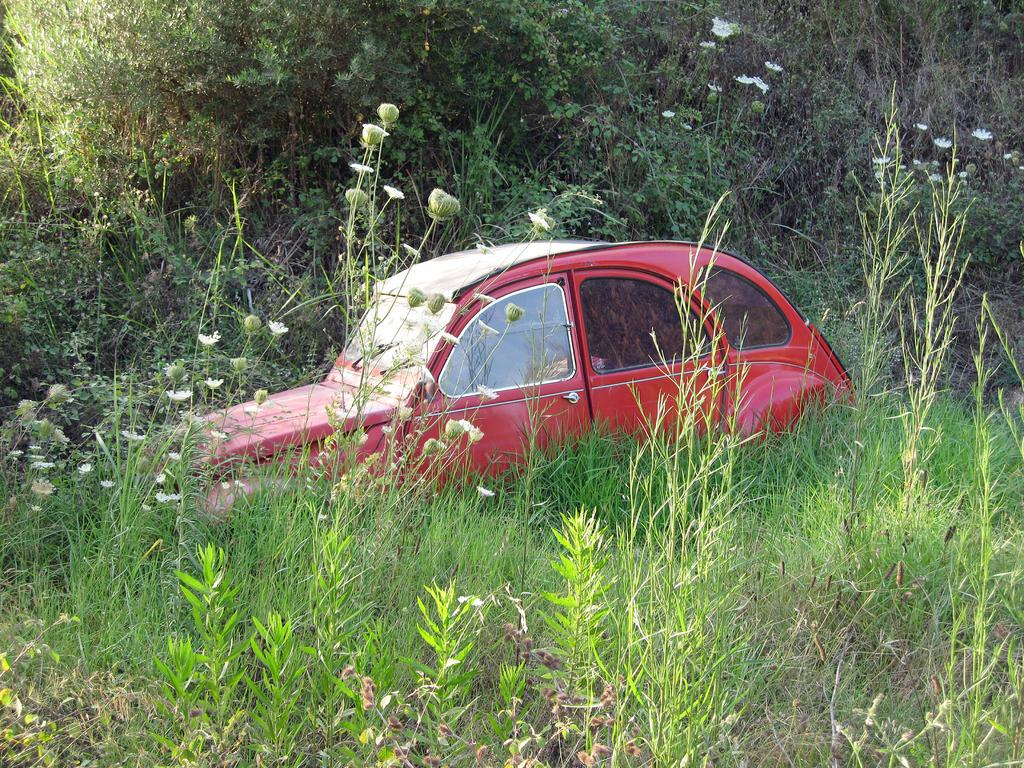What color is the car in the image? The car in the image is red. What can be seen around the car? Plants and grass are visible around the car. Are there any other natural elements in the image? Yes, trees are present in the image. What type of soup is being served in the image? There is no soup present in the image; it features a red car surrounded by plants, grass, and trees. Is there a book visible in the image? There is no book present in the image. 